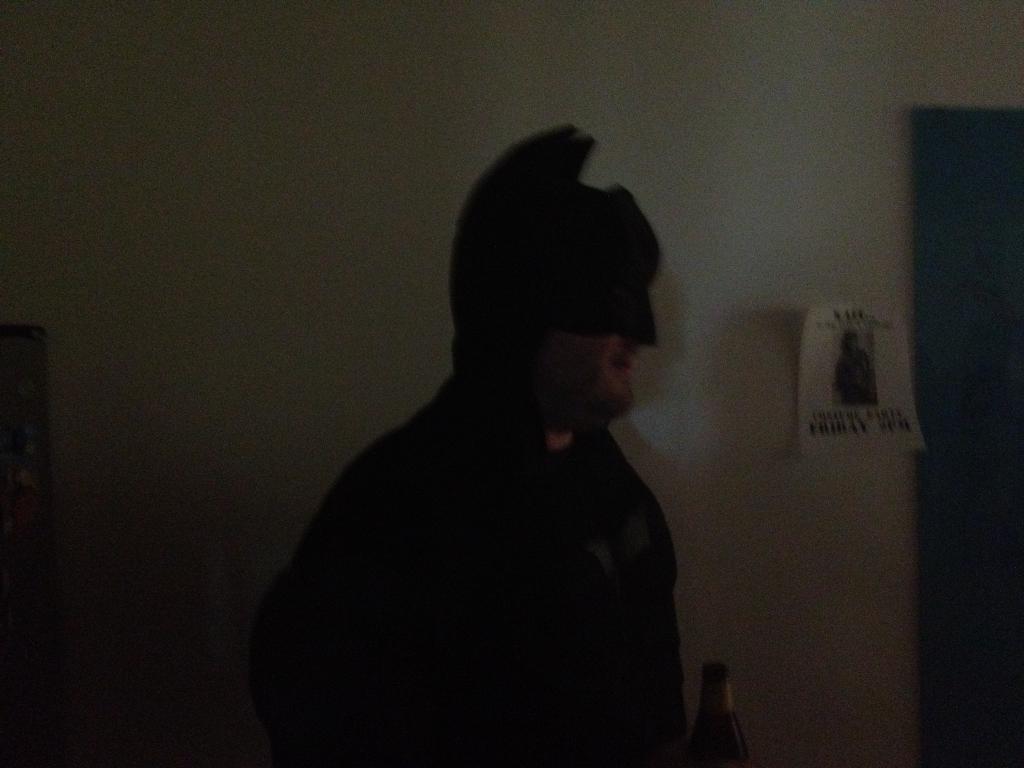Describe this image in one or two sentences. Here there is a man in batman getup. Behind him there is wall and a poster on it. Here we can see a wine bottle. 